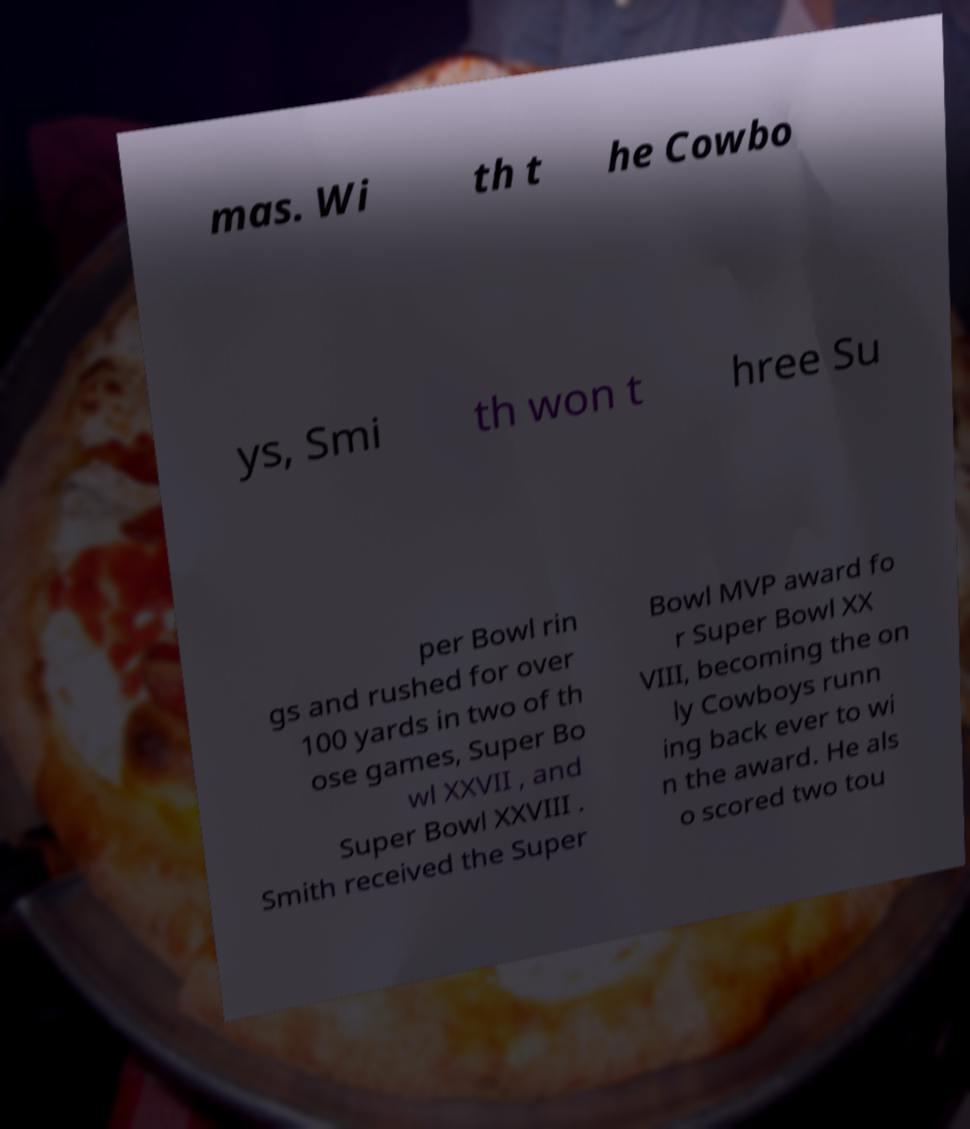Please read and relay the text visible in this image. What does it say? mas. Wi th t he Cowbo ys, Smi th won t hree Su per Bowl rin gs and rushed for over 100 yards in two of th ose games, Super Bo wl XXVII , and Super Bowl XXVIII . Smith received the Super Bowl MVP award fo r Super Bowl XX VIII, becoming the on ly Cowboys runn ing back ever to wi n the award. He als o scored two tou 